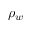<formula> <loc_0><loc_0><loc_500><loc_500>\rho _ { w }</formula> 